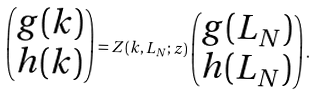Convert formula to latex. <formula><loc_0><loc_0><loc_500><loc_500>\begin{pmatrix} g ( k ) \\ h ( k ) \\ \end{pmatrix} = Z ( k , L _ { N } ; z ) \begin{pmatrix} g ( L _ { N } ) \\ h ( L _ { N } ) \\ \end{pmatrix} .</formula> 